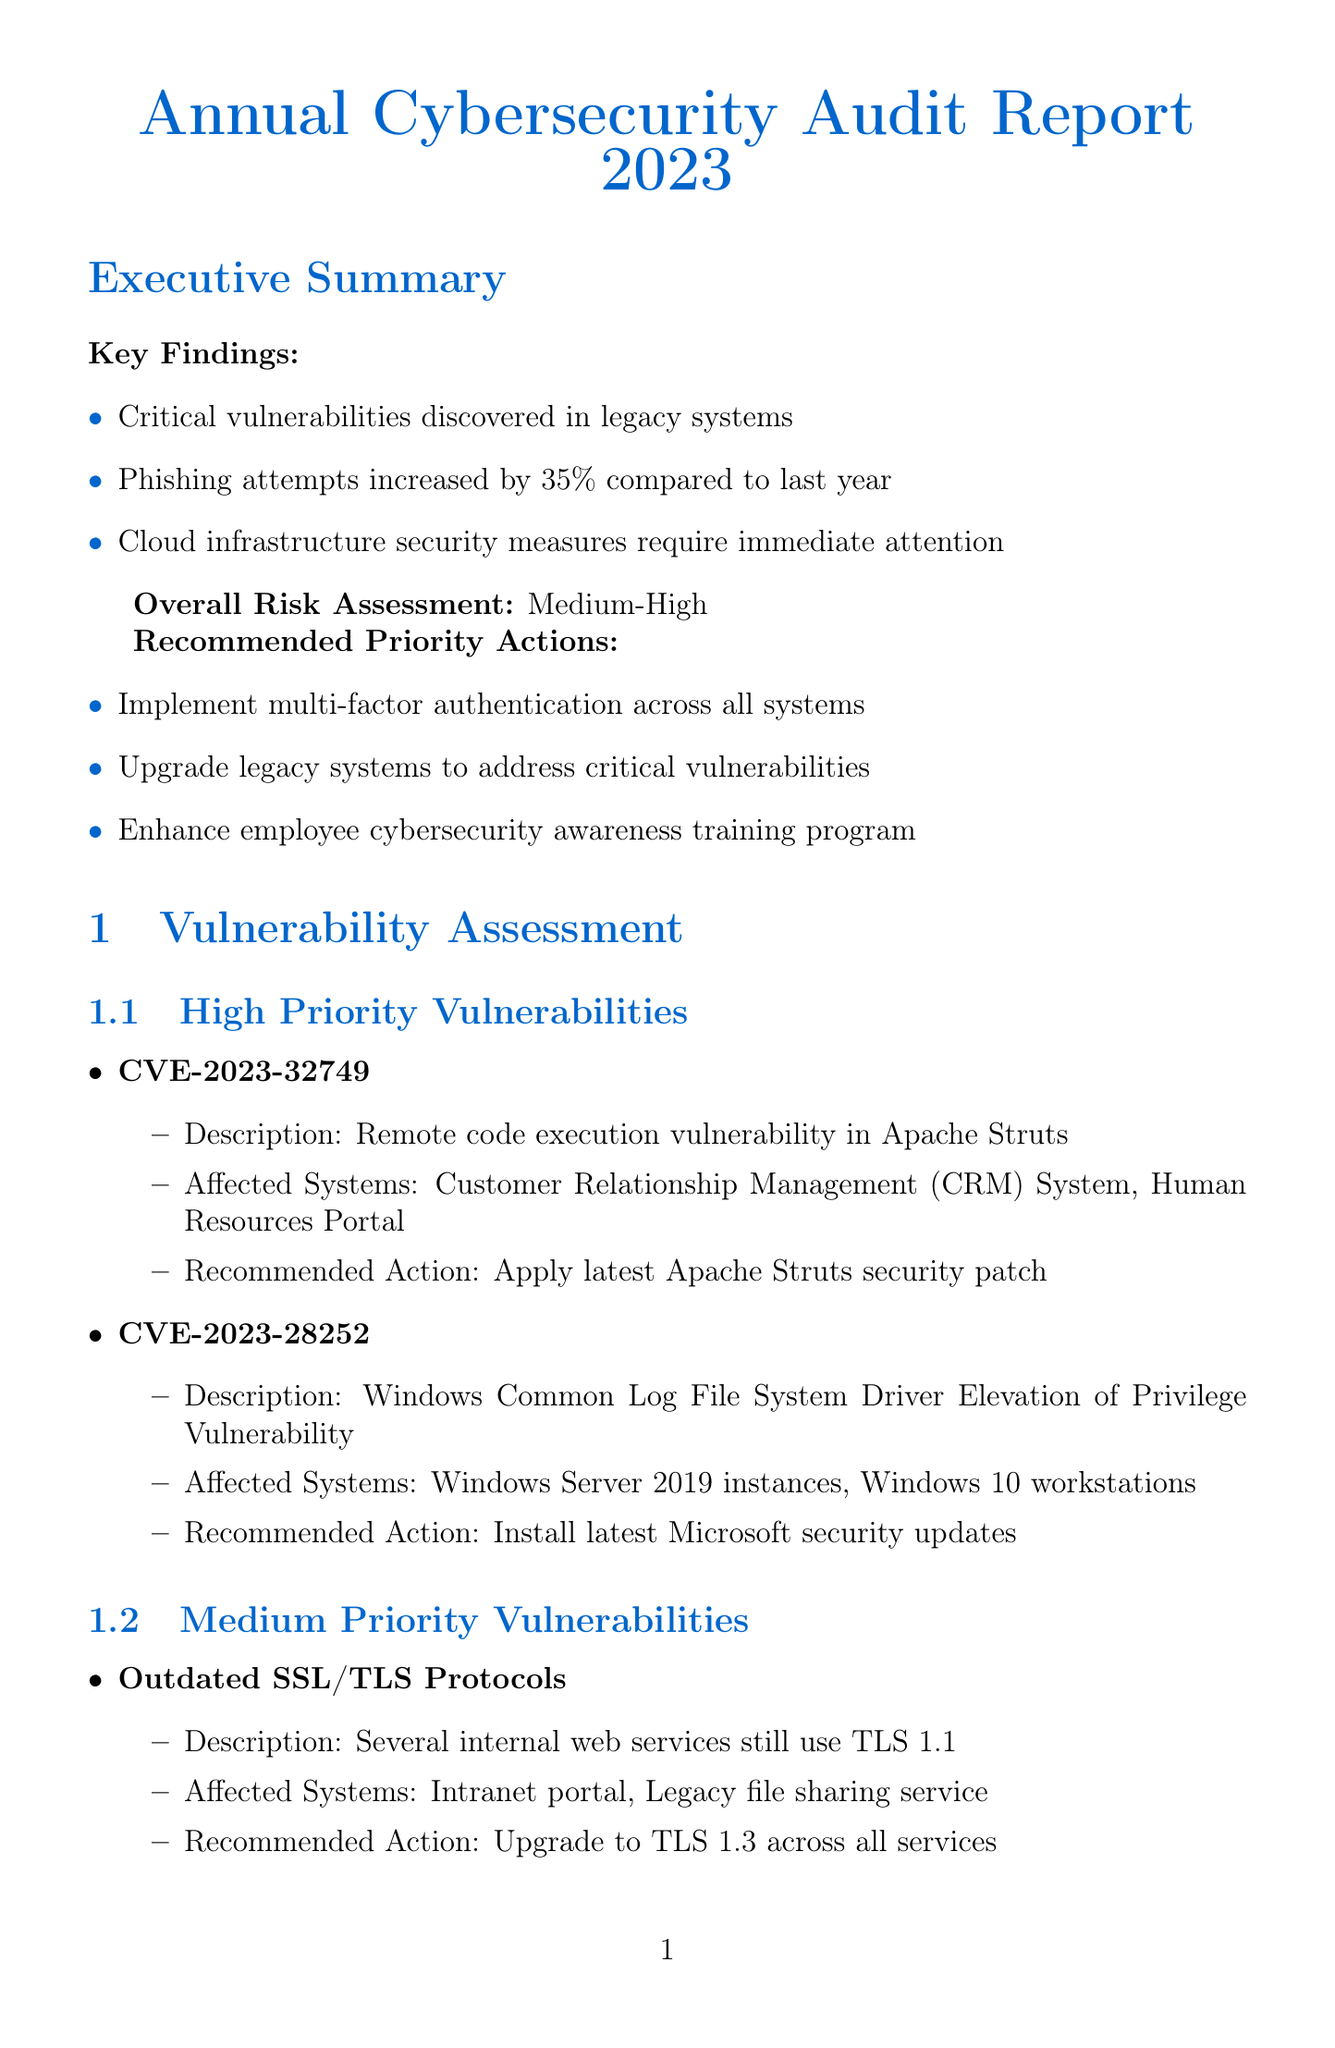What are the key findings of the audit? The key findings highlight critical issues that were discovered during the audit, such as vulnerabilities and increased threats.
Answer: Critical vulnerabilities discovered in legacy systems, Phishing attempts increased by 35% compared to last year, Cloud infrastructure security measures require immediate attention What is the overall risk assessment rating? The overall risk assessment provides an indication of the organization's current cybersecurity risk level.
Answer: Medium-High How many total incidents were reported? This number reflects all reported security incidents during the audit period and indicates overall security activity.
Answer: 47 What is the recommended budget for cybersecurity measures? The total recommended budget is a crucial figure for planning and allocating resources for cybersecurity improvements.
Answer: $2,750,000 What is the estimated timeline for the implementation of Zero Trust Architecture? This timeline provides insight into how long it will take to fully adopt a specific security strategy within the organization.
Answer: 12-18 months What vulnerability impacts the Human Resources Portal? This question addresses specific systems affected by identified vulnerabilities, helping prioritize remediation efforts.
Answer: CVE-2023-32749 What percentage of employees completed the security awareness training? This statistic helps evaluate the effectiveness of the training programs and overall employee engagement in cybersecurity initiatives.
Answer: 78% What threat type has a high-risk level according to the assessment? Identifying threats by their risk level is critical for prioritizing security efforts and resource allocation.
Answer: Ransomware 